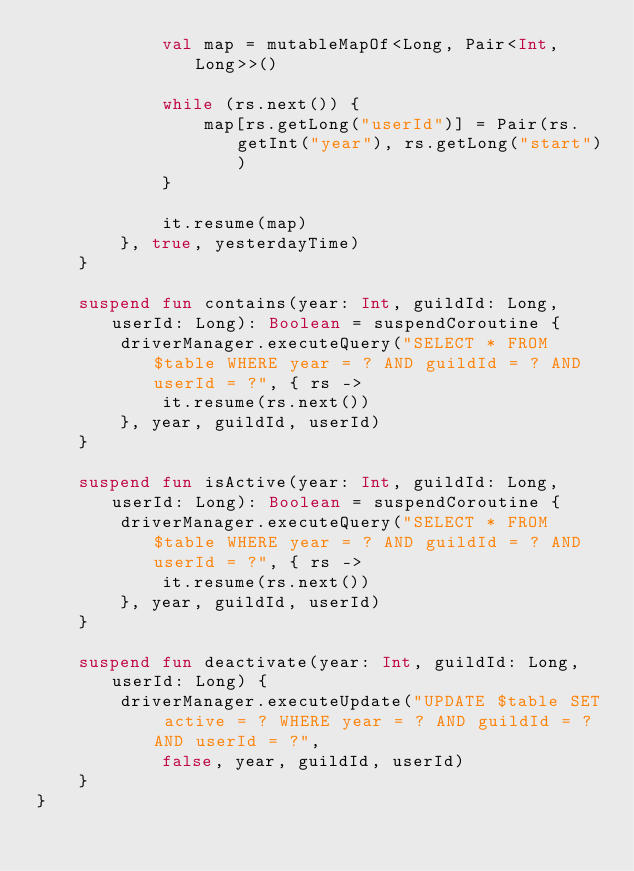Convert code to text. <code><loc_0><loc_0><loc_500><loc_500><_Kotlin_>            val map = mutableMapOf<Long, Pair<Int, Long>>()

            while (rs.next()) {
                map[rs.getLong("userId")] = Pair(rs.getInt("year"), rs.getLong("start"))
            }

            it.resume(map)
        }, true, yesterdayTime)
    }

    suspend fun contains(year: Int, guildId: Long, userId: Long): Boolean = suspendCoroutine {
        driverManager.executeQuery("SELECT * FROM $table WHERE year = ? AND guildId = ? AND userId = ?", { rs ->
            it.resume(rs.next())
        }, year, guildId, userId)
    }

    suspend fun isActive(year: Int, guildId: Long, userId: Long): Boolean = suspendCoroutine {
        driverManager.executeQuery("SELECT * FROM $table WHERE year = ? AND guildId = ? AND userId = ?", { rs ->
            it.resume(rs.next())
        }, year, guildId, userId)
    }

    suspend fun deactivate(year: Int, guildId: Long, userId: Long) {
        driverManager.executeUpdate("UPDATE $table SET active = ? WHERE year = ? AND guildId = ? AND userId = ?",
            false, year, guildId, userId)
    }
}</code> 